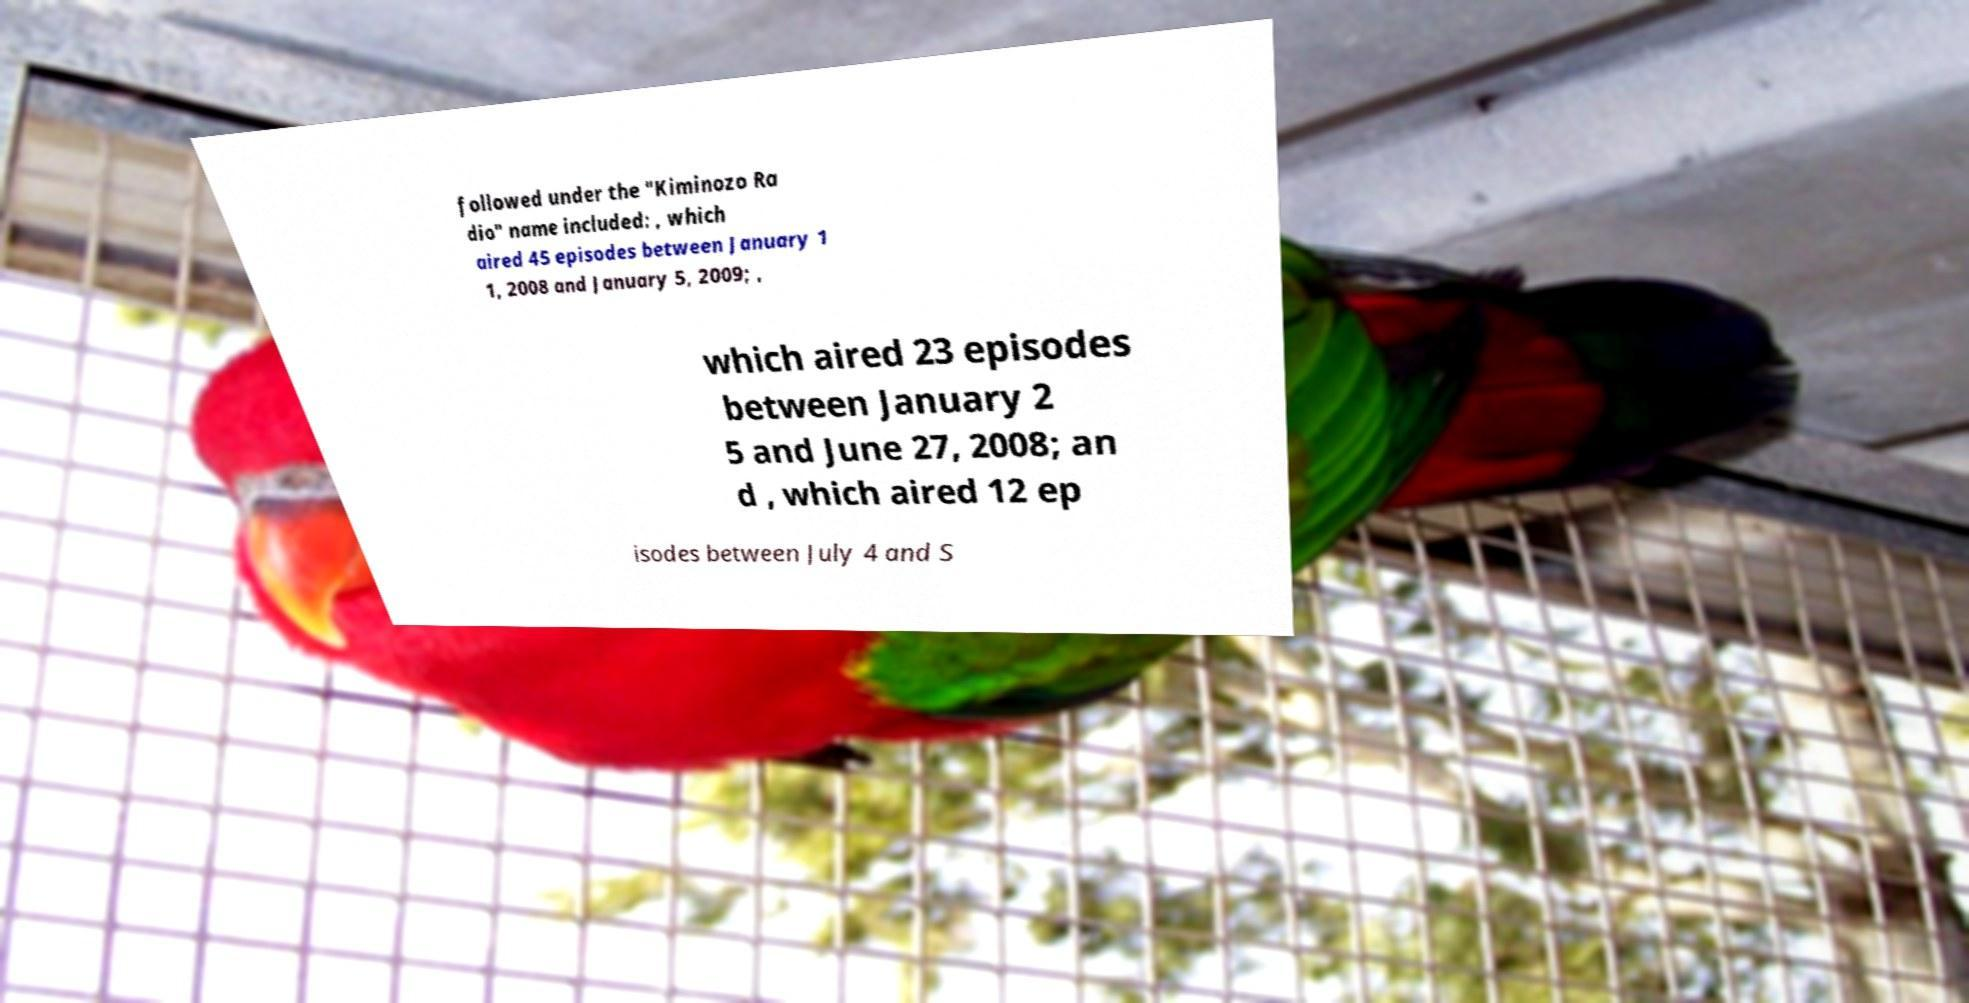What messages or text are displayed in this image? I need them in a readable, typed format. followed under the "Kiminozo Ra dio" name included: , which aired 45 episodes between January 1 1, 2008 and January 5, 2009; , which aired 23 episodes between January 2 5 and June 27, 2008; an d , which aired 12 ep isodes between July 4 and S 